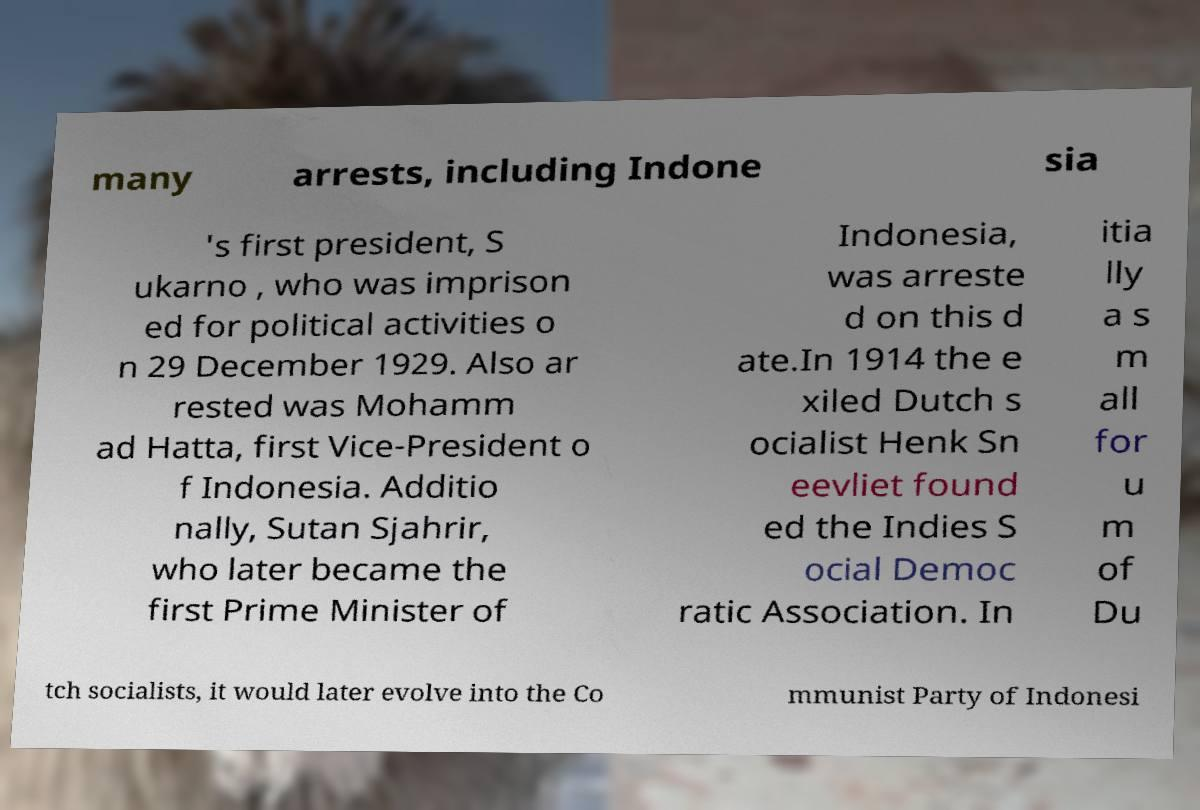Could you assist in decoding the text presented in this image and type it out clearly? many arrests, including Indone sia 's first president, S ukarno , who was imprison ed for political activities o n 29 December 1929. Also ar rested was Mohamm ad Hatta, first Vice-President o f Indonesia. Additio nally, Sutan Sjahrir, who later became the first Prime Minister of Indonesia, was arreste d on this d ate.In 1914 the e xiled Dutch s ocialist Henk Sn eevliet found ed the Indies S ocial Democ ratic Association. In itia lly a s m all for u m of Du tch socialists, it would later evolve into the Co mmunist Party of Indonesi 